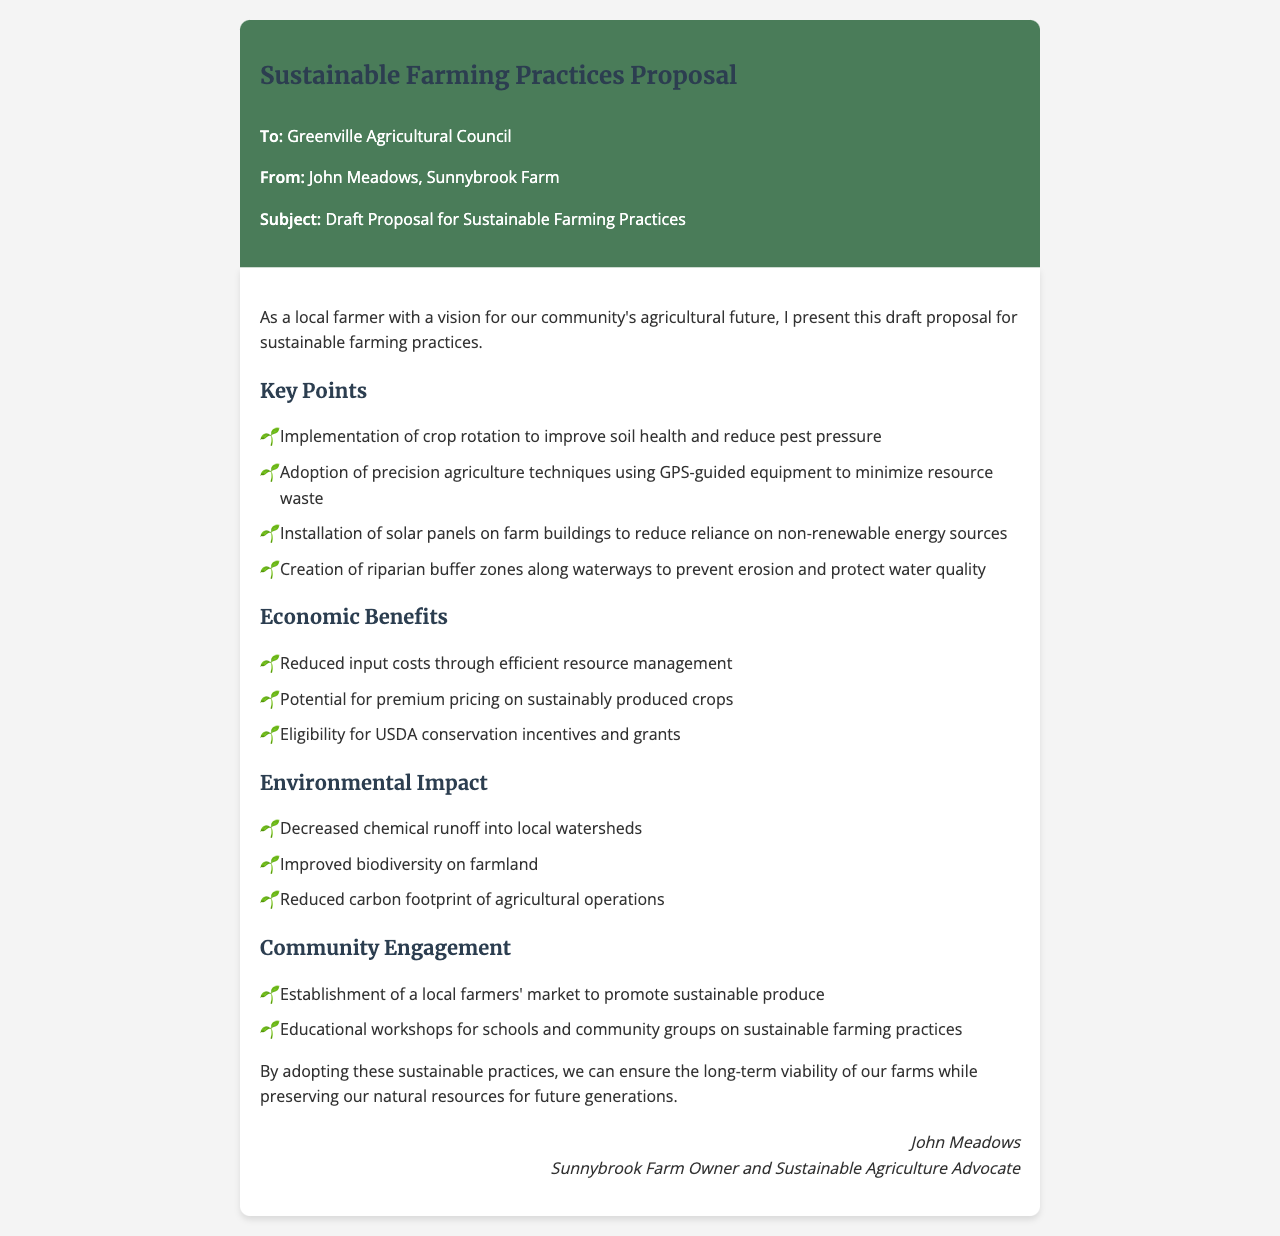what is the main topic of the proposal? The proposal focuses on sustainable farming practices aimed at improving local agriculture.
Answer: Sustainable Farming Practices Proposal who is the sender of the fax? The sender is the person who is presenting the proposal to the council.
Answer: John Meadows what is one method proposed to improve soil health? The proposal includes several practices to enhance farming, including crop rotation.
Answer: crop rotation what are the environmental benefits of adopting these practices? The document outlines several positive environmental impacts, necessary for understanding the proposal's advantages.
Answer: Decreased chemical runoff into local watersheds what is a potential economic benefit mentioned? The text discusses various economic incentives that can result from implementing sustainable practices.
Answer: Reduced input costs through efficient resource management how many key points are listed in the proposal? To determine the thoroughness of the proposal, one can count the key points outlined.
Answer: 4 what kind of workshops are proposed for community engagement? The proposal mentions educational initiatives to promote awareness about sustainable practices.
Answer: Educational workshops what is one way to support local produce mentioned in the document? The proposal suggests a community-oriented initiative to enhance local marketing.
Answer: Establishment of a local farmers' market who is the intended audience for the fax? Understanding the recipient helps contextualize the proposal's focus and purpose.
Answer: Greenville Agricultural Council 